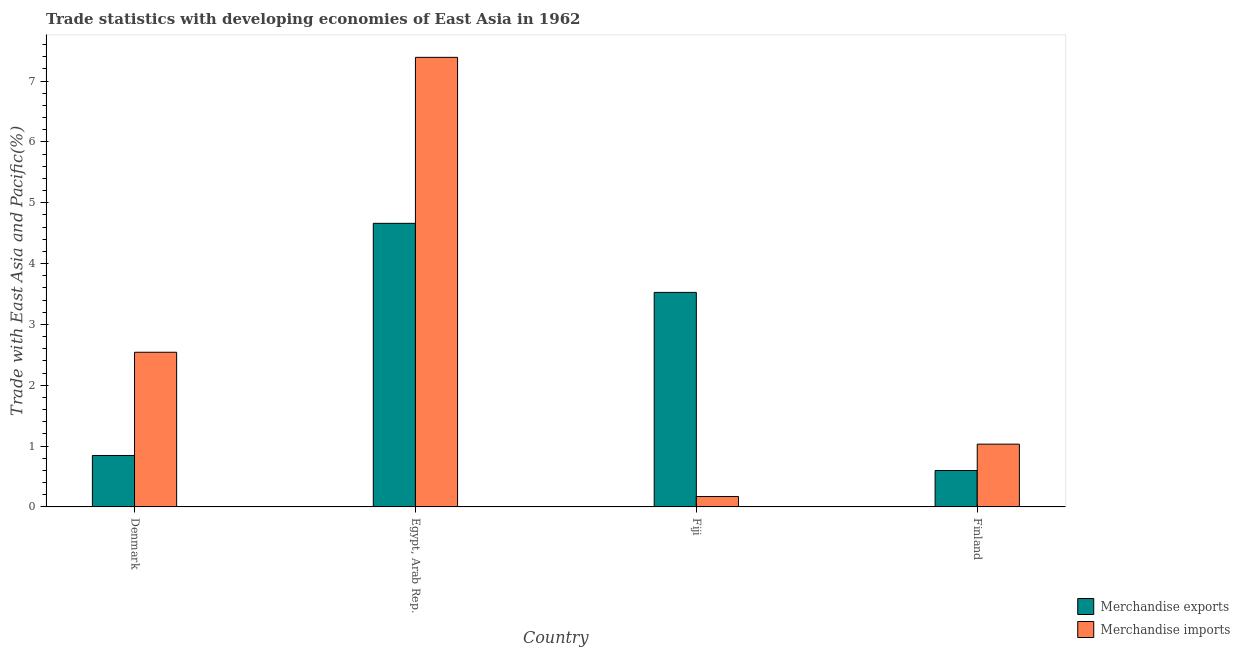How many different coloured bars are there?
Offer a very short reply. 2. How many bars are there on the 2nd tick from the right?
Provide a succinct answer. 2. What is the label of the 2nd group of bars from the left?
Offer a very short reply. Egypt, Arab Rep. In how many cases, is the number of bars for a given country not equal to the number of legend labels?
Provide a succinct answer. 0. What is the merchandise exports in Finland?
Offer a very short reply. 0.6. Across all countries, what is the maximum merchandise imports?
Provide a succinct answer. 7.39. Across all countries, what is the minimum merchandise imports?
Provide a short and direct response. 0.17. In which country was the merchandise imports maximum?
Keep it short and to the point. Egypt, Arab Rep. In which country was the merchandise imports minimum?
Your answer should be compact. Fiji. What is the total merchandise imports in the graph?
Offer a very short reply. 11.14. What is the difference between the merchandise exports in Egypt, Arab Rep. and that in Finland?
Provide a succinct answer. 4.06. What is the difference between the merchandise exports in Egypt, Arab Rep. and the merchandise imports in Finland?
Make the answer very short. 3.63. What is the average merchandise imports per country?
Provide a short and direct response. 2.78. What is the difference between the merchandise exports and merchandise imports in Denmark?
Keep it short and to the point. -1.7. What is the ratio of the merchandise exports in Egypt, Arab Rep. to that in Finland?
Ensure brevity in your answer.  7.79. What is the difference between the highest and the second highest merchandise imports?
Your answer should be compact. 4.85. What is the difference between the highest and the lowest merchandise exports?
Provide a succinct answer. 4.06. In how many countries, is the merchandise exports greater than the average merchandise exports taken over all countries?
Provide a succinct answer. 2. Is the sum of the merchandise imports in Denmark and Egypt, Arab Rep. greater than the maximum merchandise exports across all countries?
Provide a succinct answer. Yes. What does the 1st bar from the left in Fiji represents?
Keep it short and to the point. Merchandise exports. What does the 2nd bar from the right in Egypt, Arab Rep. represents?
Ensure brevity in your answer.  Merchandise exports. How many bars are there?
Your answer should be compact. 8. Are all the bars in the graph horizontal?
Keep it short and to the point. No. How many countries are there in the graph?
Offer a very short reply. 4. Does the graph contain any zero values?
Offer a terse response. No. How are the legend labels stacked?
Give a very brief answer. Vertical. What is the title of the graph?
Your answer should be very brief. Trade statistics with developing economies of East Asia in 1962. Does "Electricity and heat production" appear as one of the legend labels in the graph?
Provide a short and direct response. No. What is the label or title of the X-axis?
Provide a short and direct response. Country. What is the label or title of the Y-axis?
Give a very brief answer. Trade with East Asia and Pacific(%). What is the Trade with East Asia and Pacific(%) of Merchandise exports in Denmark?
Your answer should be very brief. 0.85. What is the Trade with East Asia and Pacific(%) in Merchandise imports in Denmark?
Make the answer very short. 2.54. What is the Trade with East Asia and Pacific(%) in Merchandise exports in Egypt, Arab Rep.?
Keep it short and to the point. 4.66. What is the Trade with East Asia and Pacific(%) in Merchandise imports in Egypt, Arab Rep.?
Give a very brief answer. 7.39. What is the Trade with East Asia and Pacific(%) of Merchandise exports in Fiji?
Your answer should be very brief. 3.53. What is the Trade with East Asia and Pacific(%) of Merchandise imports in Fiji?
Provide a short and direct response. 0.17. What is the Trade with East Asia and Pacific(%) of Merchandise exports in Finland?
Keep it short and to the point. 0.6. What is the Trade with East Asia and Pacific(%) of Merchandise imports in Finland?
Keep it short and to the point. 1.03. Across all countries, what is the maximum Trade with East Asia and Pacific(%) of Merchandise exports?
Ensure brevity in your answer.  4.66. Across all countries, what is the maximum Trade with East Asia and Pacific(%) in Merchandise imports?
Keep it short and to the point. 7.39. Across all countries, what is the minimum Trade with East Asia and Pacific(%) in Merchandise exports?
Make the answer very short. 0.6. Across all countries, what is the minimum Trade with East Asia and Pacific(%) in Merchandise imports?
Provide a short and direct response. 0.17. What is the total Trade with East Asia and Pacific(%) of Merchandise exports in the graph?
Your response must be concise. 9.63. What is the total Trade with East Asia and Pacific(%) in Merchandise imports in the graph?
Give a very brief answer. 11.14. What is the difference between the Trade with East Asia and Pacific(%) in Merchandise exports in Denmark and that in Egypt, Arab Rep.?
Make the answer very short. -3.82. What is the difference between the Trade with East Asia and Pacific(%) in Merchandise imports in Denmark and that in Egypt, Arab Rep.?
Offer a terse response. -4.85. What is the difference between the Trade with East Asia and Pacific(%) of Merchandise exports in Denmark and that in Fiji?
Provide a succinct answer. -2.68. What is the difference between the Trade with East Asia and Pacific(%) of Merchandise imports in Denmark and that in Fiji?
Keep it short and to the point. 2.37. What is the difference between the Trade with East Asia and Pacific(%) of Merchandise exports in Denmark and that in Finland?
Offer a terse response. 0.25. What is the difference between the Trade with East Asia and Pacific(%) of Merchandise imports in Denmark and that in Finland?
Your answer should be compact. 1.51. What is the difference between the Trade with East Asia and Pacific(%) of Merchandise exports in Egypt, Arab Rep. and that in Fiji?
Your answer should be compact. 1.14. What is the difference between the Trade with East Asia and Pacific(%) in Merchandise imports in Egypt, Arab Rep. and that in Fiji?
Provide a succinct answer. 7.22. What is the difference between the Trade with East Asia and Pacific(%) in Merchandise exports in Egypt, Arab Rep. and that in Finland?
Ensure brevity in your answer.  4.06. What is the difference between the Trade with East Asia and Pacific(%) in Merchandise imports in Egypt, Arab Rep. and that in Finland?
Ensure brevity in your answer.  6.36. What is the difference between the Trade with East Asia and Pacific(%) in Merchandise exports in Fiji and that in Finland?
Your answer should be compact. 2.93. What is the difference between the Trade with East Asia and Pacific(%) of Merchandise imports in Fiji and that in Finland?
Offer a very short reply. -0.86. What is the difference between the Trade with East Asia and Pacific(%) in Merchandise exports in Denmark and the Trade with East Asia and Pacific(%) in Merchandise imports in Egypt, Arab Rep.?
Provide a succinct answer. -6.54. What is the difference between the Trade with East Asia and Pacific(%) of Merchandise exports in Denmark and the Trade with East Asia and Pacific(%) of Merchandise imports in Fiji?
Make the answer very short. 0.67. What is the difference between the Trade with East Asia and Pacific(%) of Merchandise exports in Denmark and the Trade with East Asia and Pacific(%) of Merchandise imports in Finland?
Your answer should be compact. -0.19. What is the difference between the Trade with East Asia and Pacific(%) in Merchandise exports in Egypt, Arab Rep. and the Trade with East Asia and Pacific(%) in Merchandise imports in Fiji?
Keep it short and to the point. 4.49. What is the difference between the Trade with East Asia and Pacific(%) in Merchandise exports in Egypt, Arab Rep. and the Trade with East Asia and Pacific(%) in Merchandise imports in Finland?
Your answer should be very brief. 3.63. What is the difference between the Trade with East Asia and Pacific(%) in Merchandise exports in Fiji and the Trade with East Asia and Pacific(%) in Merchandise imports in Finland?
Make the answer very short. 2.49. What is the average Trade with East Asia and Pacific(%) of Merchandise exports per country?
Your answer should be very brief. 2.41. What is the average Trade with East Asia and Pacific(%) in Merchandise imports per country?
Offer a terse response. 2.78. What is the difference between the Trade with East Asia and Pacific(%) in Merchandise exports and Trade with East Asia and Pacific(%) in Merchandise imports in Denmark?
Your answer should be very brief. -1.7. What is the difference between the Trade with East Asia and Pacific(%) of Merchandise exports and Trade with East Asia and Pacific(%) of Merchandise imports in Egypt, Arab Rep.?
Provide a succinct answer. -2.73. What is the difference between the Trade with East Asia and Pacific(%) in Merchandise exports and Trade with East Asia and Pacific(%) in Merchandise imports in Fiji?
Provide a short and direct response. 3.36. What is the difference between the Trade with East Asia and Pacific(%) of Merchandise exports and Trade with East Asia and Pacific(%) of Merchandise imports in Finland?
Ensure brevity in your answer.  -0.43. What is the ratio of the Trade with East Asia and Pacific(%) in Merchandise exports in Denmark to that in Egypt, Arab Rep.?
Offer a terse response. 0.18. What is the ratio of the Trade with East Asia and Pacific(%) of Merchandise imports in Denmark to that in Egypt, Arab Rep.?
Ensure brevity in your answer.  0.34. What is the ratio of the Trade with East Asia and Pacific(%) of Merchandise exports in Denmark to that in Fiji?
Keep it short and to the point. 0.24. What is the ratio of the Trade with East Asia and Pacific(%) in Merchandise imports in Denmark to that in Fiji?
Give a very brief answer. 14.87. What is the ratio of the Trade with East Asia and Pacific(%) of Merchandise exports in Denmark to that in Finland?
Provide a succinct answer. 1.41. What is the ratio of the Trade with East Asia and Pacific(%) of Merchandise imports in Denmark to that in Finland?
Give a very brief answer. 2.46. What is the ratio of the Trade with East Asia and Pacific(%) in Merchandise exports in Egypt, Arab Rep. to that in Fiji?
Provide a short and direct response. 1.32. What is the ratio of the Trade with East Asia and Pacific(%) of Merchandise imports in Egypt, Arab Rep. to that in Fiji?
Your answer should be compact. 43.21. What is the ratio of the Trade with East Asia and Pacific(%) in Merchandise exports in Egypt, Arab Rep. to that in Finland?
Offer a terse response. 7.79. What is the ratio of the Trade with East Asia and Pacific(%) of Merchandise imports in Egypt, Arab Rep. to that in Finland?
Give a very brief answer. 7.16. What is the ratio of the Trade with East Asia and Pacific(%) in Merchandise exports in Fiji to that in Finland?
Give a very brief answer. 5.89. What is the ratio of the Trade with East Asia and Pacific(%) of Merchandise imports in Fiji to that in Finland?
Offer a terse response. 0.17. What is the difference between the highest and the second highest Trade with East Asia and Pacific(%) in Merchandise exports?
Your answer should be compact. 1.14. What is the difference between the highest and the second highest Trade with East Asia and Pacific(%) of Merchandise imports?
Offer a very short reply. 4.85. What is the difference between the highest and the lowest Trade with East Asia and Pacific(%) of Merchandise exports?
Give a very brief answer. 4.06. What is the difference between the highest and the lowest Trade with East Asia and Pacific(%) of Merchandise imports?
Offer a very short reply. 7.22. 